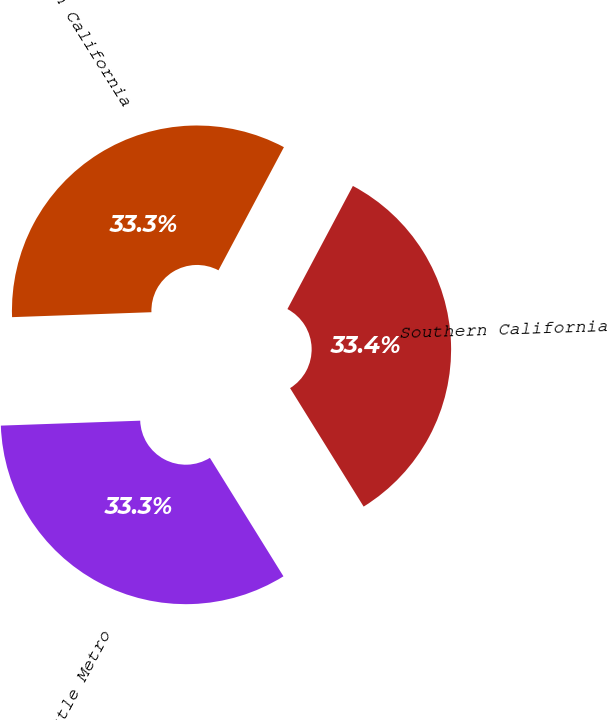<chart> <loc_0><loc_0><loc_500><loc_500><pie_chart><fcel>Southern California<fcel>Northern California<fcel>Seattle Metro<nl><fcel>33.38%<fcel>33.34%<fcel>33.28%<nl></chart> 